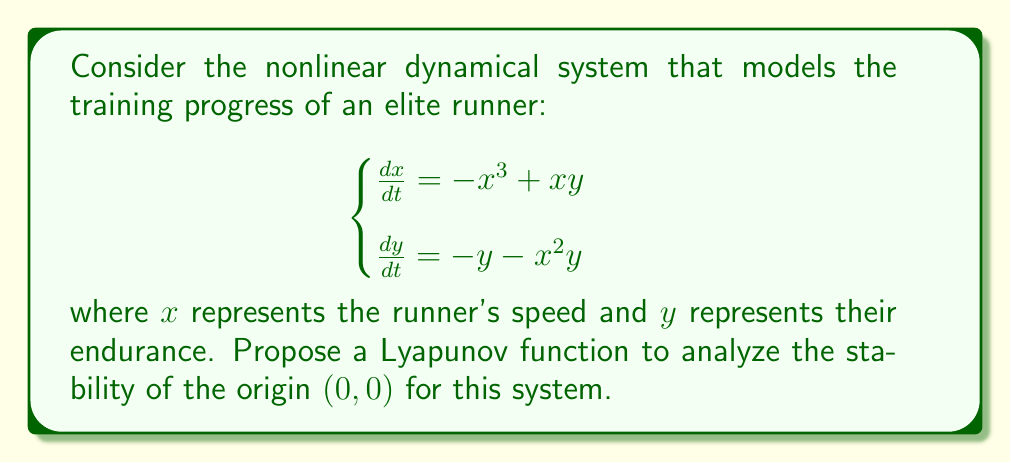Provide a solution to this math problem. To analyze the stability of the origin for this nonlinear system, we'll follow these steps:

1) Propose a Lyapunov function candidate:
   Let's consider $V(x,y) = \frac{1}{2}(x^2 + y^2)$

2) Check if $V(x,y)$ is positive definite:
   $V(x,y) = \frac{1}{2}(x^2 + y^2) > 0$ for all $(x,y) \neq (0,0)$, and $V(0,0) = 0$
   So, $V(x,y)$ is positive definite.

3) Calculate the time derivative of $V(x,y)$:
   $$\begin{align}
   \frac{dV}{dt} &= \frac{\partial V}{\partial x}\frac{dx}{dt} + \frac{\partial V}{\partial y}\frac{dy}{dt} \\
   &= x(-x^3+xy) + y(-y-x^2y) \\
   &= -x^4 + x^2y - y^2 - x^2y^2 \\
   &= -(x^4 + y^2) - x^2y^2
   \end{align}$$

4) Analyze $\frac{dV}{dt}$:
   $\frac{dV}{dt} = -(x^4 + y^2) - x^2y^2 < 0$ for all $(x,y) \neq (0,0)$, and $\frac{dV}{dt}(0,0) = 0$
   So, $\frac{dV}{dt}$ is negative definite.

5) Conclude:
   Since $V(x,y)$ is positive definite and $\frac{dV}{dt}$ is negative definite, by Lyapunov's stability theorem, the origin $(0,0)$ is asymptotically stable.
Answer: $V(x,y) = \frac{1}{2}(x^2 + y^2)$ 